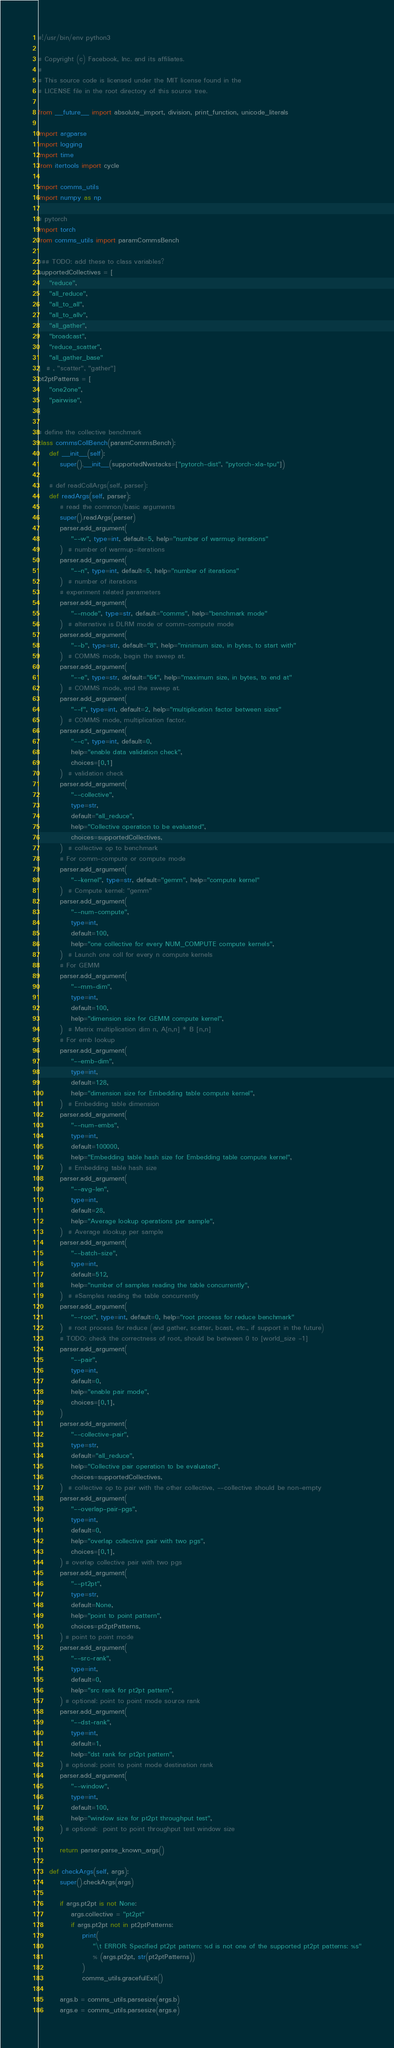<code> <loc_0><loc_0><loc_500><loc_500><_Python_>#!/usr/bin/env python3

# Copyright (c) Facebook, Inc. and its affiliates.
#
# This source code is licensed under the MIT license found in the
# LICENSE file in the root directory of this source tree.

from __future__ import absolute_import, division, print_function, unicode_literals

import argparse
import logging
import time
from itertools import cycle

import comms_utils
import numpy as np

# pytorch
import torch
from comms_utils import paramCommsBench

### TODO: add these to class variables?
supportedCollectives = [
    "reduce",
    "all_reduce",
    "all_to_all",
    "all_to_allv",
    "all_gather",
    "broadcast",
    "reduce_scatter",
    "all_gather_base"
]  # , "scatter", "gather"]
pt2ptPatterns = [
    "one2one",
    "pairwise",
]

# define the collective benchmark
class commsCollBench(paramCommsBench):
    def __init__(self):
        super().__init__(supportedNwstacks=["pytorch-dist", "pytorch-xla-tpu"])

    # def readCollArgs(self, parser):
    def readArgs(self, parser):
        # read the common/basic arguments
        super().readArgs(parser)
        parser.add_argument(
            "--w", type=int, default=5, help="number of warmup iterations"
        )  # number of warmup-iterations
        parser.add_argument(
            "--n", type=int, default=5, help="number of iterations"
        )  # number of iterations
        # experiment related parameters
        parser.add_argument(
            "--mode", type=str, default="comms", help="benchmark mode"
        )  # alternative is DLRM mode or comm-compute mode
        parser.add_argument(
            "--b", type=str, default="8", help="minimum size, in bytes, to start with"
        )  # COMMS mode, begin the sweep at.
        parser.add_argument(
            "--e", type=str, default="64", help="maximum size, in bytes, to end at"
        )  # COMMS mode, end the sweep at.
        parser.add_argument(
            "--f", type=int, default=2, help="multiplication factor between sizes"
        )  # COMMS mode, multiplication factor.
        parser.add_argument(
            "--c", type=int, default=0,
            help="enable data validation check",
            choices=[0,1]
        )  # validation check
        parser.add_argument(
            "--collective",
            type=str,
            default="all_reduce",
            help="Collective operation to be evaluated",
            choices=supportedCollectives,
        )  # collective op to benchmark
        # For comm-compute or compute mode
        parser.add_argument(
            "--kernel", type=str, default="gemm", help="compute kernel"
        )  # Compute kernel: "gemm"
        parser.add_argument(
            "--num-compute",
            type=int,
            default=100,
            help="one collective for every NUM_COMPUTE compute kernels",
        )  # Launch one coll for every n compute kernels
        # For GEMM
        parser.add_argument(
            "--mm-dim",
            type=int,
            default=100,
            help="dimension size for GEMM compute kernel",
        )  # Matrix multiplication dim n, A[n,n] * B [n,n]
        # For emb lookup
        parser.add_argument(
            "--emb-dim",
            type=int,
            default=128,
            help="dimension size for Embedding table compute kernel",
        )  # Embedding table dimension
        parser.add_argument(
            "--num-embs",
            type=int,
            default=100000,
            help="Embedding table hash size for Embedding table compute kernel",
        )  # Embedding table hash size
        parser.add_argument(
            "--avg-len",
            type=int,
            default=28,
            help="Average lookup operations per sample",
        )  # Average #lookup per sample
        parser.add_argument(
            "--batch-size",
            type=int,
            default=512,
            help="number of samples reading the table concurrently",
        )  # #Samples reading the table concurrently
        parser.add_argument(
            "--root", type=int, default=0, help="root process for reduce benchmark"
        )  # root process for reduce (and gather, scatter, bcast, etc., if support in the future)
        # TODO: check the correctness of root, should be between 0 to [world_size -1]
        parser.add_argument(
            "--pair",
            type=int,
            default=0,
            help="enable pair mode",
            choices=[0,1],
        )
        parser.add_argument(
            "--collective-pair",
            type=str,
            default="all_reduce",
            help="Collective pair operation to be evaluated",
            choices=supportedCollectives,
        )  # collective op to pair with the other collective, --collective should be non-empty
        parser.add_argument(
            "--overlap-pair-pgs",
            type=int,
            default=0,
            help="overlap collective pair with two pgs",
            choices=[0,1],
        ) # overlap collective pair with two pgs
        parser.add_argument(
            "--pt2pt",
            type=str,
            default=None,
            help="point to point pattern",
            choices=pt2ptPatterns,
        ) # point to point mode
        parser.add_argument(
            "--src-rank",
            type=int,
            default=0,
            help="src rank for pt2pt pattern",
        ) # optional: point to point mode source rank
        parser.add_argument(
            "--dst-rank",
            type=int,
            default=1,
            help="dst rank for pt2pt pattern",
        ) # optional: point to point mode destination rank
        parser.add_argument(
            "--window",
            type=int,
            default=100,
            help="window size for pt2pt throughput test",
        ) # optional:  point to point throughput test window size

        return parser.parse_known_args()

    def checkArgs(self, args):
        super().checkArgs(args)

        if args.pt2pt is not None:
            args.collective = "pt2pt"
            if args.pt2pt not in pt2ptPatterns:
                print(
                    "\t ERROR: Specified pt2pt pattern: %d is not one of the supported pt2pt patterns: %s"
                    % (args.pt2pt, str(pt2ptPatterns))
                )
                comms_utils.gracefulExit()

        args.b = comms_utils.parsesize(args.b)
        args.e = comms_utils.parsesize(args.e)</code> 